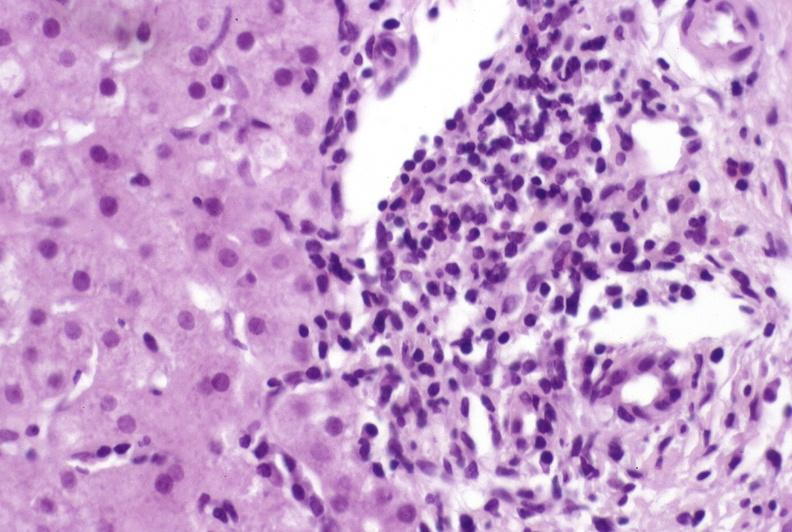what is present?
Answer the question using a single word or phrase. Liver 